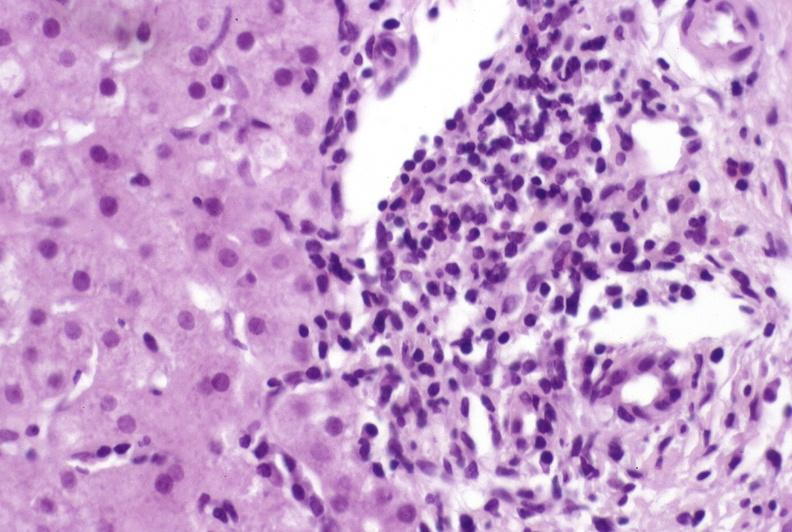what is present?
Answer the question using a single word or phrase. Liver 